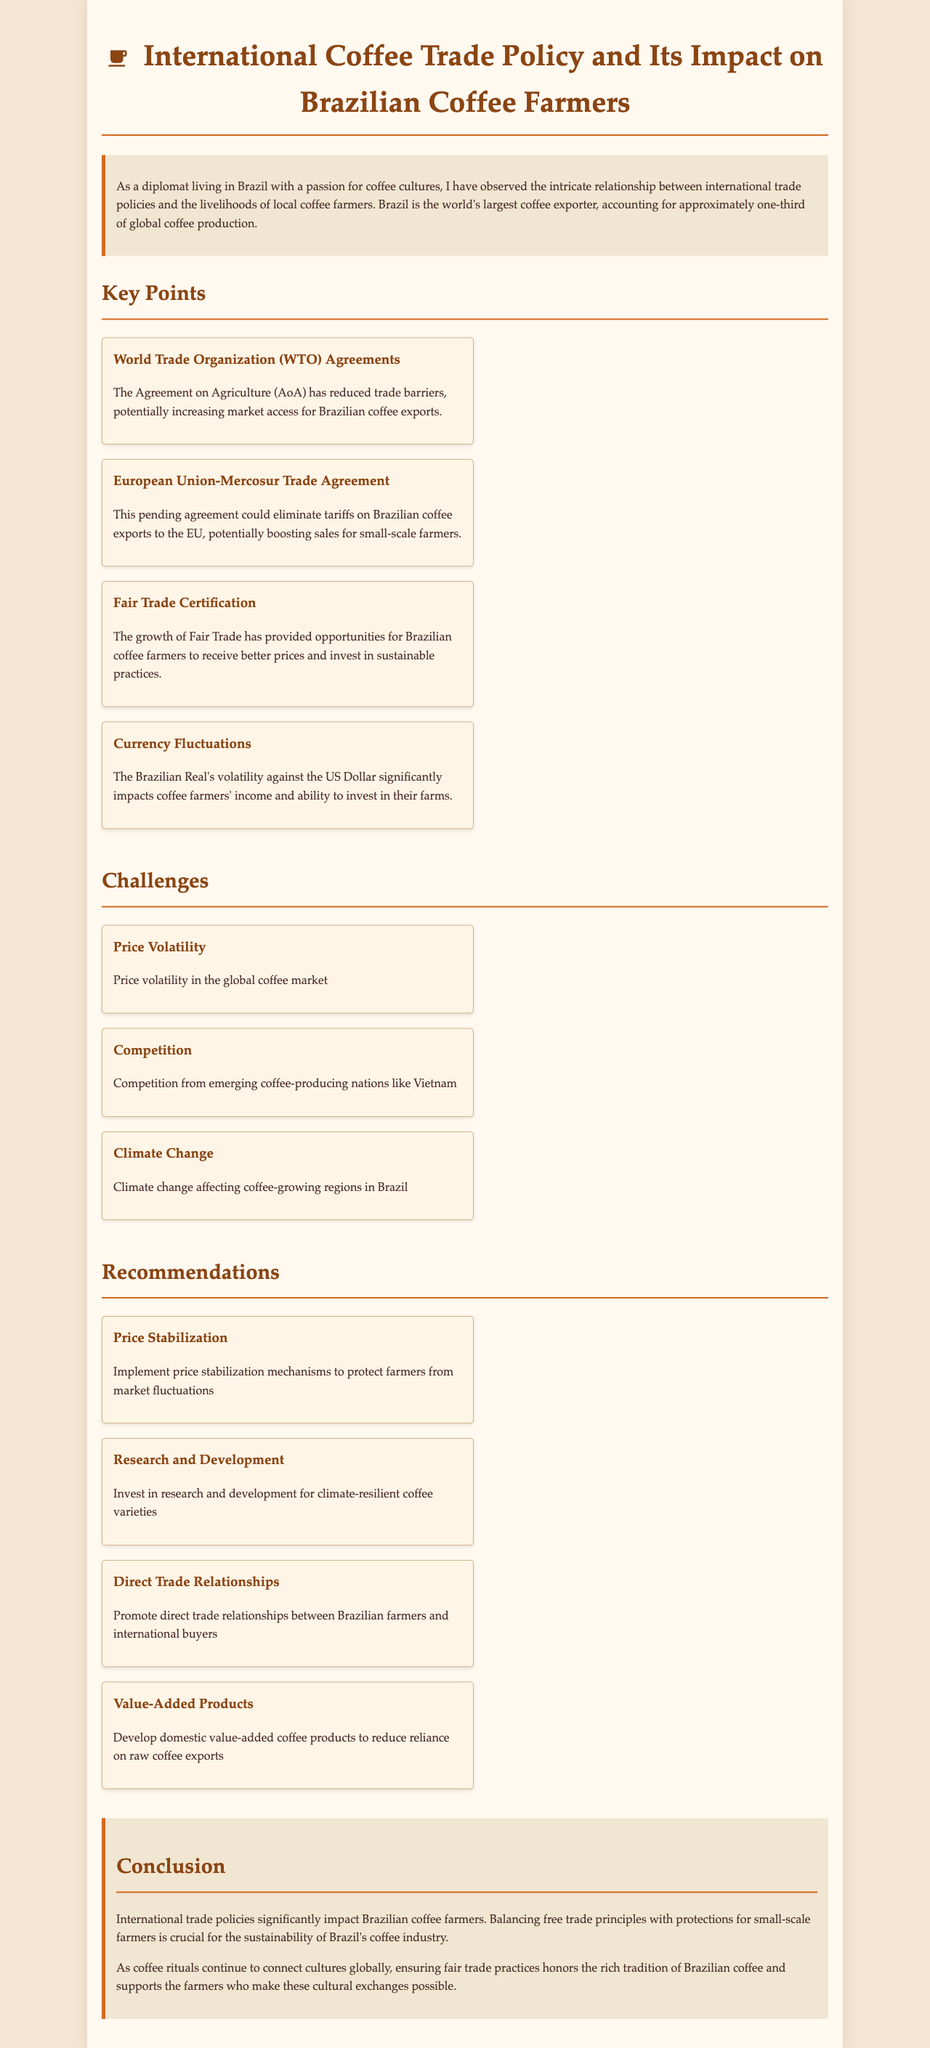What percentage of global coffee production does Brazil account for? The document states that Brazil accounts for approximately one-third of global coffee production.
Answer: one-third What type of trade agreement could boost Brazilian coffee sales to the EU? The document mentions the pending European Union-Mercosur Trade Agreement which could eliminate tariffs.
Answer: European Union-Mercosur Trade Agreement What is a significant challenge Brazilian coffee farmers face according to the document? The document lists price volatility in the global coffee market as a challenge for farmers.
Answer: Price volatility What is one recommendation for supporting Brazilian coffee farmers? The document suggests implementing price stabilization mechanisms to protect farmers.
Answer: Price stabilization mechanisms What does Fair Trade certification provide Brazilian coffee farmers? The document indicates that Fair Trade provides opportunities for better prices and investment in sustainable practices.
Answer: Better prices and investment in sustainable practices How does climate change affect Brazilian coffee production? The document points out that climate change is affecting coffee-growing regions in Brazil.
Answer: Affecting coffee-growing regions What are direct trade relationships aimed at? The document states that promoting direct trade relationships is meant to connect Brazilian farmers with international buyers.
Answer: Connecting farmers with international buyers What is the main conclusion drawn in the document? The conclusion emphasizes that balancing free trade principles with protections for farmers is crucial for sustainability.
Answer: Balancing free trade principles with protections for farmers 